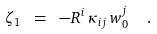Convert formula to latex. <formula><loc_0><loc_0><loc_500><loc_500>\zeta _ { 1 } \ = \ - R ^ { i } \, \kappa _ { i j } \, w ^ { j } _ { 0 } \ \ .</formula> 